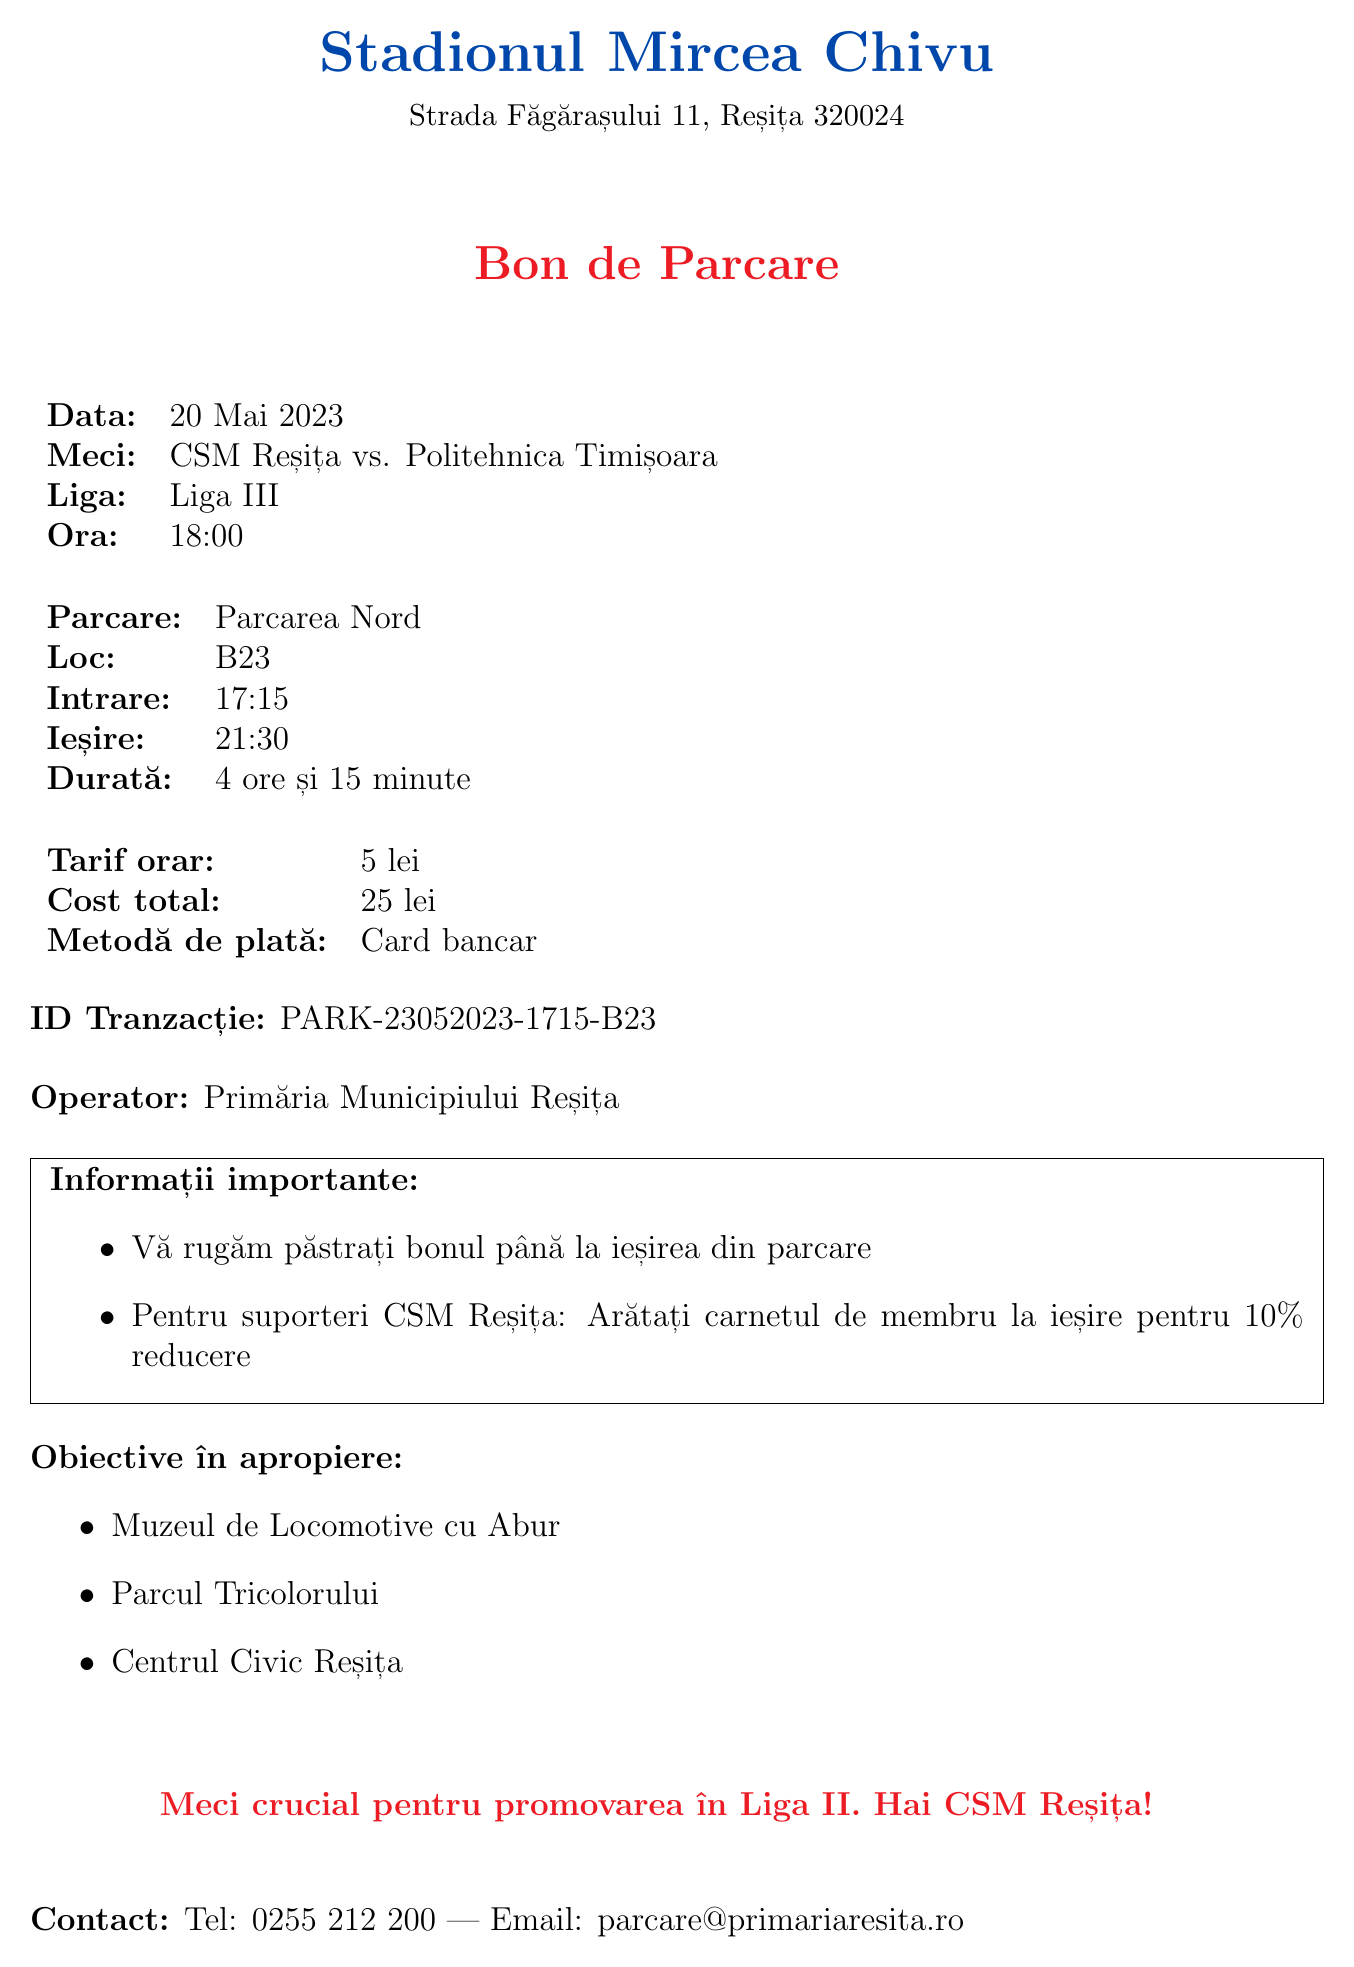What is the name of the stadium? The name of the stadium is explicitly stated in the document.
Answer: Stadionul Mircea Chivu What time did the match start? The start time of the match is provided in the match details section.
Answer: 18:00 How long was the parking duration? The parking duration is calculated and mentioned in the parking info section.
Answer: 4 ore și 15 minute What is the total cost of parking? The total cost is indicated in the pricing section of the document.
Answer: 25 lei Which two teams played in the match? The teams are listed in the match details section of the document.
Answer: CSM Reșița vs. Politehnica Timișoara What is the hourly parking rate? The hourly rate is mentioned in the pricing section.
Answer: 5 lei What ID is associated with this transaction? The transaction ID is provided in a specific part of the receipt.
Answer: PARK-23052023-1715-B23 What method of payment was used? The payment method is specified in the pricing section of the document.
Answer: Card bancar What should supporters show at exit for a discount? The additional information section requires supporters to show something for a discount.
Answer: carnetul de membru 